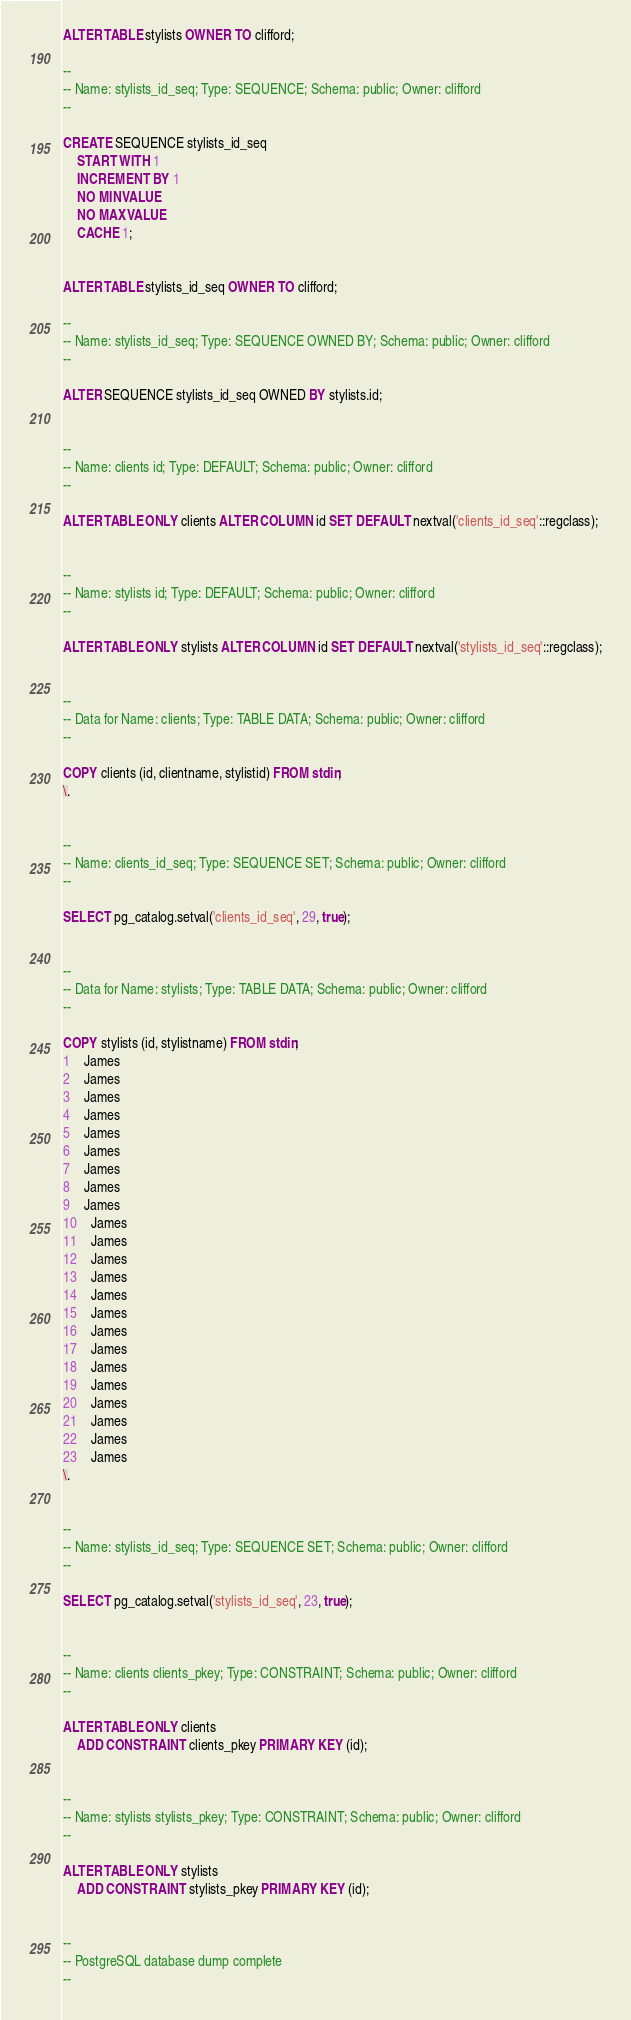Convert code to text. <code><loc_0><loc_0><loc_500><loc_500><_SQL_>ALTER TABLE stylists OWNER TO clifford;

--
-- Name: stylists_id_seq; Type: SEQUENCE; Schema: public; Owner: clifford
--

CREATE SEQUENCE stylists_id_seq
    START WITH 1
    INCREMENT BY 1
    NO MINVALUE
    NO MAXVALUE
    CACHE 1;


ALTER TABLE stylists_id_seq OWNER TO clifford;

--
-- Name: stylists_id_seq; Type: SEQUENCE OWNED BY; Schema: public; Owner: clifford
--

ALTER SEQUENCE stylists_id_seq OWNED BY stylists.id;


--
-- Name: clients id; Type: DEFAULT; Schema: public; Owner: clifford
--

ALTER TABLE ONLY clients ALTER COLUMN id SET DEFAULT nextval('clients_id_seq'::regclass);


--
-- Name: stylists id; Type: DEFAULT; Schema: public; Owner: clifford
--

ALTER TABLE ONLY stylists ALTER COLUMN id SET DEFAULT nextval('stylists_id_seq'::regclass);


--
-- Data for Name: clients; Type: TABLE DATA; Schema: public; Owner: clifford
--

COPY clients (id, clientname, stylistid) FROM stdin;
\.


--
-- Name: clients_id_seq; Type: SEQUENCE SET; Schema: public; Owner: clifford
--

SELECT pg_catalog.setval('clients_id_seq', 29, true);


--
-- Data for Name: stylists; Type: TABLE DATA; Schema: public; Owner: clifford
--

COPY stylists (id, stylistname) FROM stdin;
1	James
2	James
3	James
4	James
5	James
6	James
7	James
8	James
9	James
10	James
11	James
12	James
13	James
14	James
15	James
16	James
17	James
18	James
19	James
20	James
21	James
22	James
23	James
\.


--
-- Name: stylists_id_seq; Type: SEQUENCE SET; Schema: public; Owner: clifford
--

SELECT pg_catalog.setval('stylists_id_seq', 23, true);


--
-- Name: clients clients_pkey; Type: CONSTRAINT; Schema: public; Owner: clifford
--

ALTER TABLE ONLY clients
    ADD CONSTRAINT clients_pkey PRIMARY KEY (id);


--
-- Name: stylists stylists_pkey; Type: CONSTRAINT; Schema: public; Owner: clifford
--

ALTER TABLE ONLY stylists
    ADD CONSTRAINT stylists_pkey PRIMARY KEY (id);


--
-- PostgreSQL database dump complete
--

</code> 